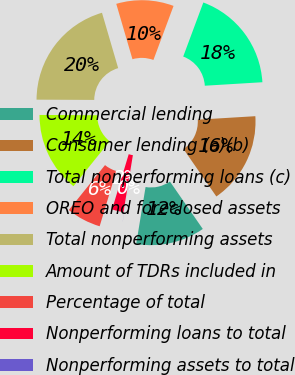Convert chart to OTSL. <chart><loc_0><loc_0><loc_500><loc_500><pie_chart><fcel>Commercial lending<fcel>Consumer lending (a)(b)<fcel>Total nonperforming loans (c)<fcel>OREO and foreclosed assets<fcel>Total nonperforming assets<fcel>Amount of TDRs included in<fcel>Percentage of total<fcel>Nonperforming loans to total<fcel>Nonperforming assets to total<nl><fcel>12.24%<fcel>16.32%<fcel>18.36%<fcel>10.2%<fcel>20.4%<fcel>14.28%<fcel>6.13%<fcel>2.05%<fcel>0.01%<nl></chart> 